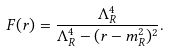Convert formula to latex. <formula><loc_0><loc_0><loc_500><loc_500>F ( r ) = \frac { \Lambda _ { R } ^ { 4 } } { \Lambda _ { R } ^ { 4 } - ( r - m _ { R } ^ { 2 } ) ^ { 2 } } .</formula> 